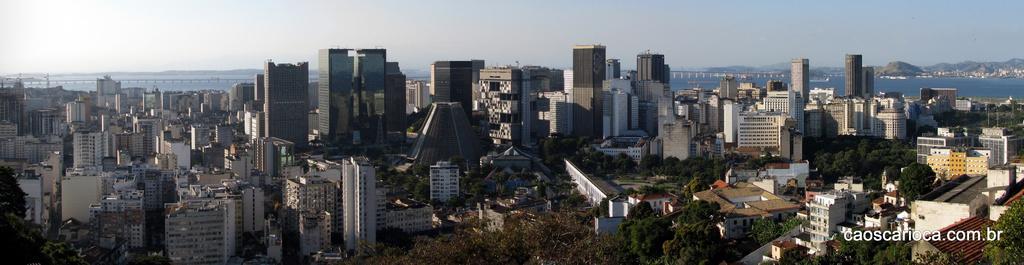How would you summarize this image in a sentence or two? In this image there are buildings, trees, water, hills, bridge, sky and objects. At the bottom right side of the image there is a watermark. 